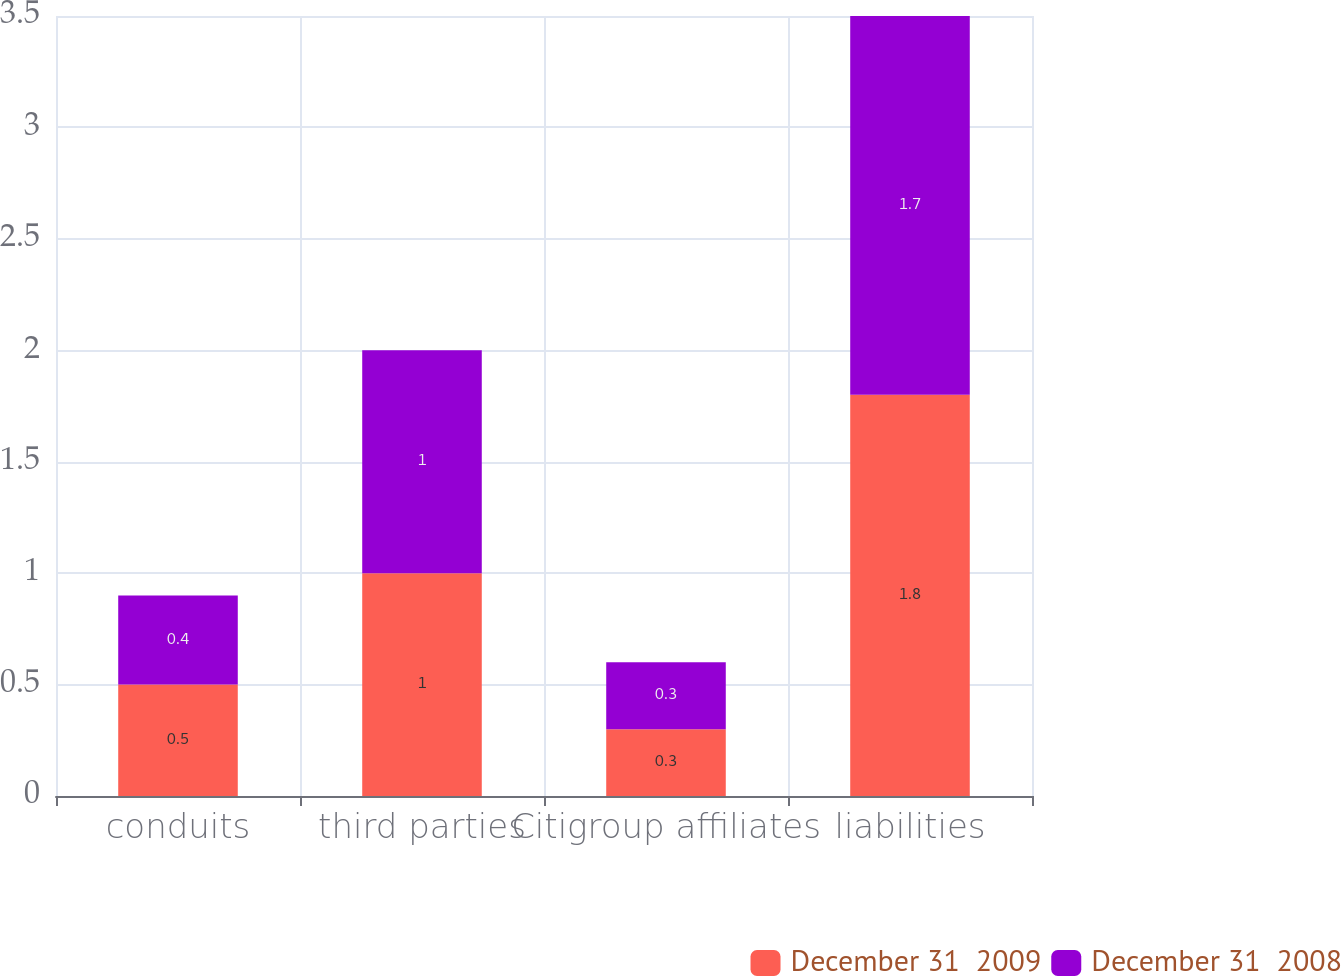Convert chart. <chart><loc_0><loc_0><loc_500><loc_500><stacked_bar_chart><ecel><fcel>conduits<fcel>third parties<fcel>Citigroup affiliates<fcel>liabilities<nl><fcel>December 31  2009<fcel>0.5<fcel>1<fcel>0.3<fcel>1.8<nl><fcel>December 31  2008<fcel>0.4<fcel>1<fcel>0.3<fcel>1.7<nl></chart> 